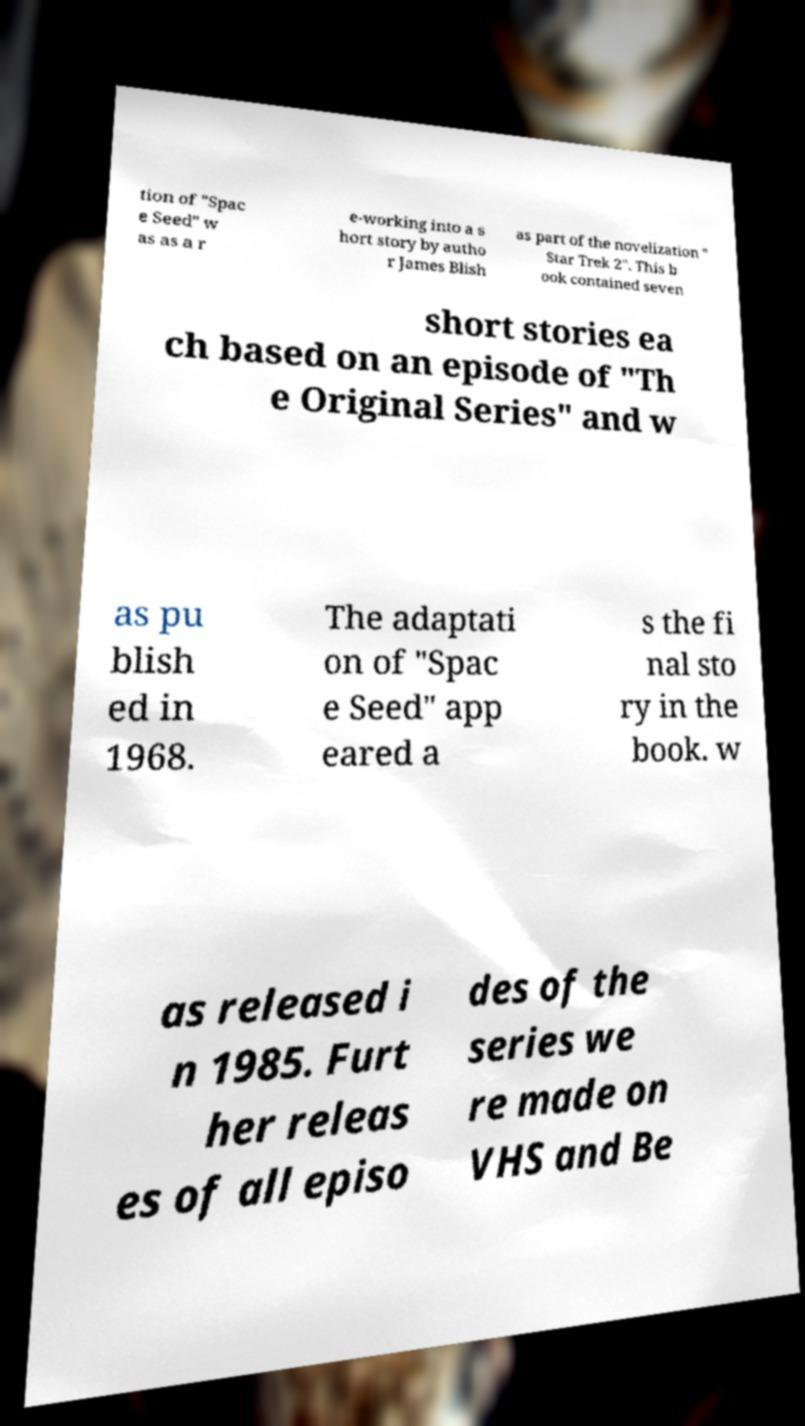Could you extract and type out the text from this image? tion of "Spac e Seed" w as as a r e-working into a s hort story by autho r James Blish as part of the novelization " Star Trek 2". This b ook contained seven short stories ea ch based on an episode of "Th e Original Series" and w as pu blish ed in 1968. The adaptati on of "Spac e Seed" app eared a s the fi nal sto ry in the book. w as released i n 1985. Furt her releas es of all episo des of the series we re made on VHS and Be 